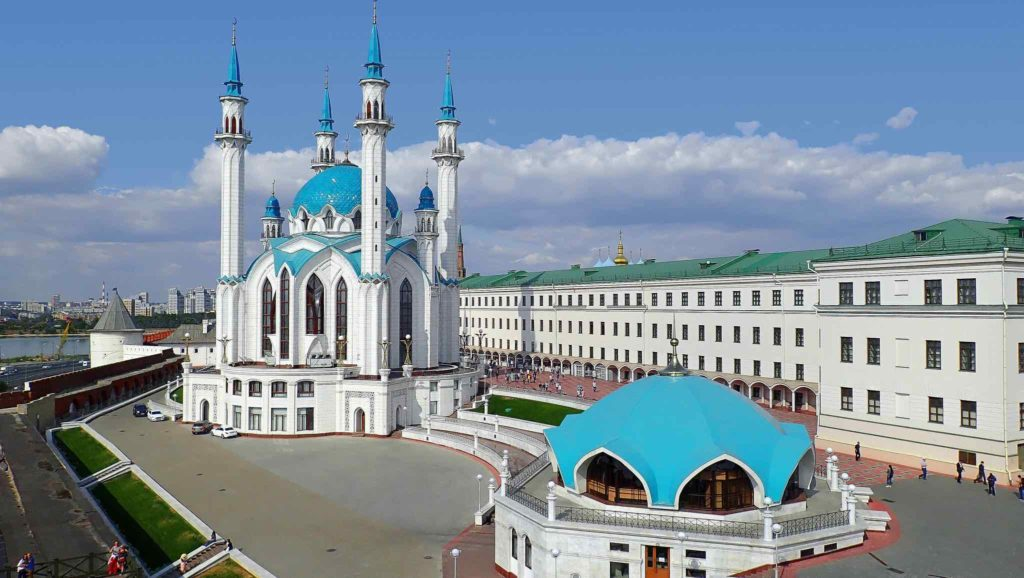Imagine this place during a historical re-enactment. What events might be featured? A historical re-enactment at the Kazan Kremlin might focus on pivotal moments such as the Siege of Kazan in 1552. Actors dressed as Russian soldiers and Tatar defenders would recreate the intense battles, showcasing the strategies and weapons used during the siege. The re-enactment could also include scenes depicting daily life in Kazan during the 16th century, with craftsmen, traders, and townsfolk going about their routines. The cultural fusion resulting from the city's diverse history could be highlighted through performances of traditional Tatar dance and music, accompanied by period-appropriate feasts where visitors sharegpt4v/sample historical dishes. The grand finale might be a dramatic retelling of the fall of Kazan and the subsequent changes it brought to the region, underscoring the resilience and cultural evolution of its inhabitants. 